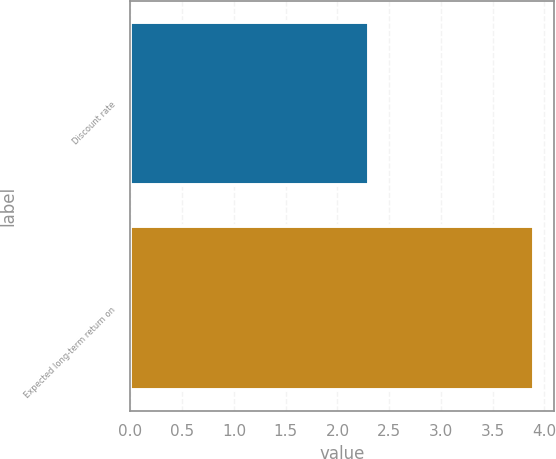Convert chart to OTSL. <chart><loc_0><loc_0><loc_500><loc_500><bar_chart><fcel>Discount rate<fcel>Expected long-term return on<nl><fcel>2.3<fcel>3.9<nl></chart> 